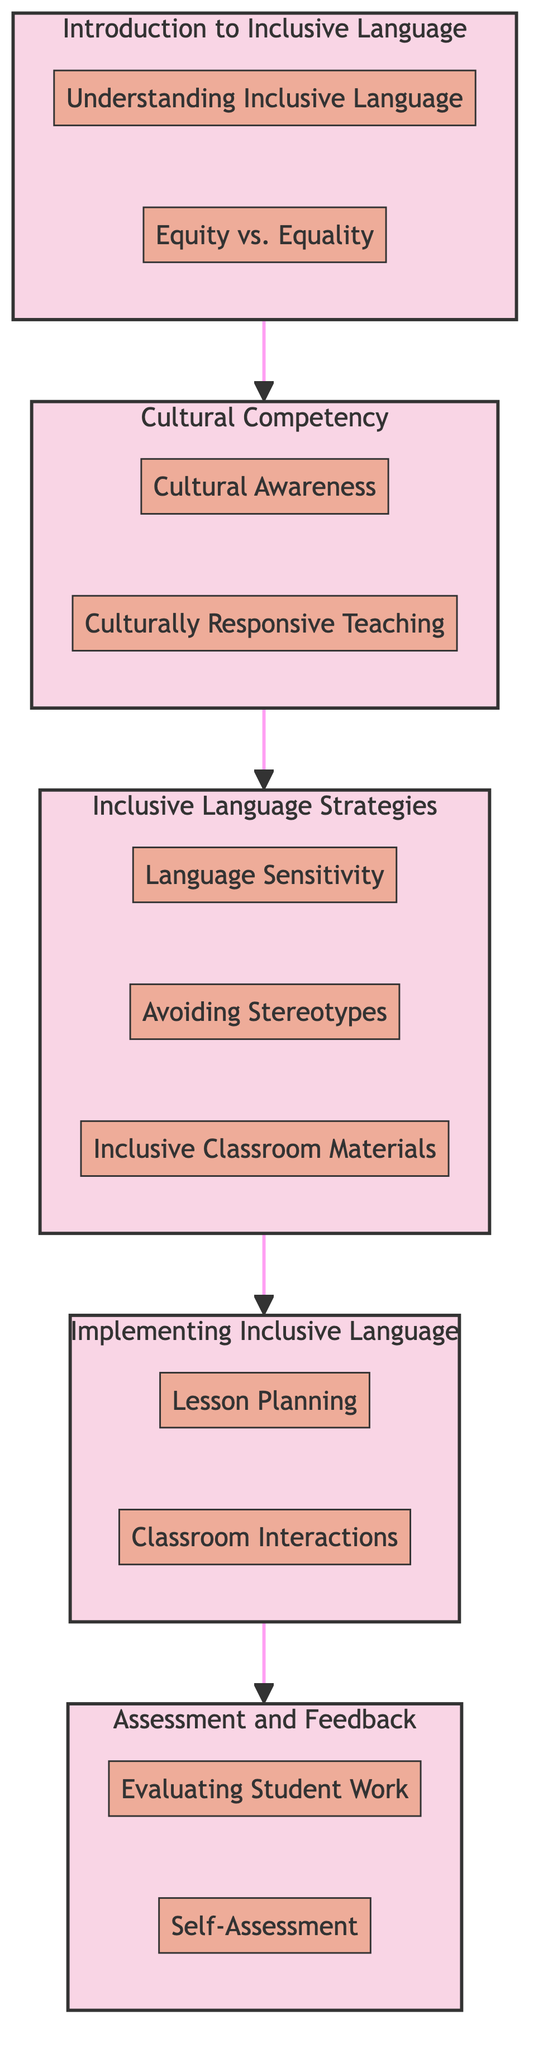What is the first module in the diagram? The first module is identified as "Introduction to Inclusive Language" at the top of the flow, indicating it is the starting point for the training sequence.
Answer: Introduction to Inclusive Language How many components are there in the "Inclusive Language Strategies" module? The "Inclusive Language Strategies" module has three components listed within its section: "Language Sensitivity," "Avoiding Stereotypes," and "Inclusive Classroom Materials."
Answer: Three What is the last module in the flow? The last module is "Assessment and Feedback," shown as the final destination after following all the arrows from the previous modules.
Answer: Assessment and Feedback Which module connects directly to "Cultural Competency"? The module that connects directly to "Cultural Competency" is "Introduction to Inclusive Language," as shown by the arrow leading from the former to the latter.
Answer: Introduction to Inclusive Language How many total modules are presented in the diagram? The diagram displays a total of five modules: "Introduction to Inclusive Language," "Cultural Competency," "Inclusive Language Strategies," "Implementing Inclusive Language," and "Assessment and Feedback."
Answer: Five Which component is associated with the "Implementing Inclusive Language" module? The "Implementing Inclusive Language" module includes two components: "Lesson Planning" and "Classroom Interactions," both listed under it.
Answer: Lesson Planning and Classroom Interactions What step follows the "Inclusive Language Strategies" module? The step that follows "Inclusive Language Strategies" is "Implementing Inclusive Language," indicating the progression in the training plan.
Answer: Implementing Inclusive Language Is there a component that addresses self-evaluation in language use? Yes, the component "Self-Assessment" within the "Assessment and Feedback" module specifically addresses teachers evaluating their own use of inclusive language.
Answer: Self-Assessment What type of teaching does the "Culturally Responsive Teaching" component promote? The "Culturally Responsive Teaching" component promotes strategies that integrate students' cultural backgrounds into teaching practices, emphasizing inclusivity.
Answer: Inclusivity 